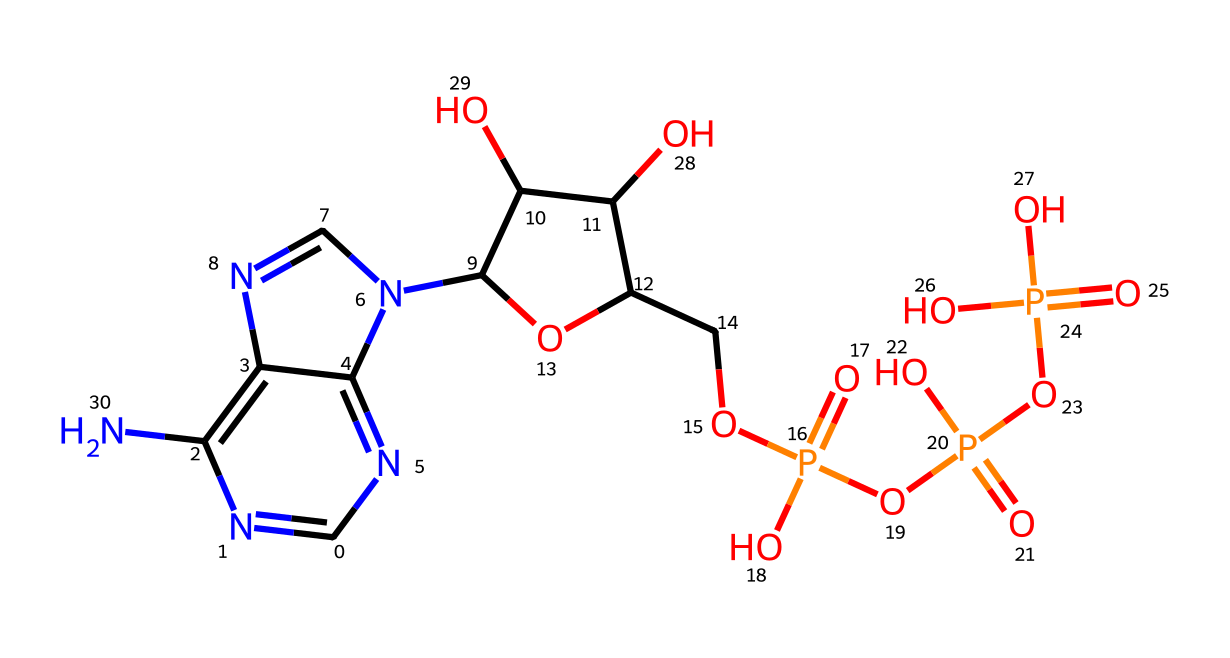What is the molecular formula of ATP? The molecular formula can be determined by counting the atoms of each element in the structure. In the provided SMILES, we count the carbon (C), hydrogen (H), nitrogen (N), oxygen (O), and phosphorus (P) atoms. The count yields C10, H15, N5, O13, and P3.
Answer: C10H15N5O13P3 How many phosphate groups are present in ATP? By analyzing the structure, we can identify the phosphate groups. In ATP, there are three phosphate groups connected in a chain, indicated in the SMILES representation.
Answer: 3 What type of bond connects the phosphate groups in ATP? The bond between the phosphate groups in ATP is referred to as a phosphoanhydride bond. We can infer this by looking at the connections between the phosphates in the structure.
Answer: phosphoanhydride How many rings are present in the structure of ATP? The counting of rings involves examining the cyclic parts of the structure. In ATP, there is one purine ring containing the nitrogen atoms, and one fused ring with a pentose sugar, yielding a total of two rings.
Answer: 2 What role does ATP play in cells? ATP functions primarily as an energy carrier in cells, as indicated by its composition and structure. The presence of high-energy phosphate bonds allows it to store and transfer energy.
Answer: energy carrier What is the primary sugar component of ATP? In the structure, we can recognize the ribose sugar, which is part of ATP’s backbone, connecting the adenosine part to the phosphate groups. This distinction comes from recognizing the 5-carbon sugar in the structure.
Answer: ribose 